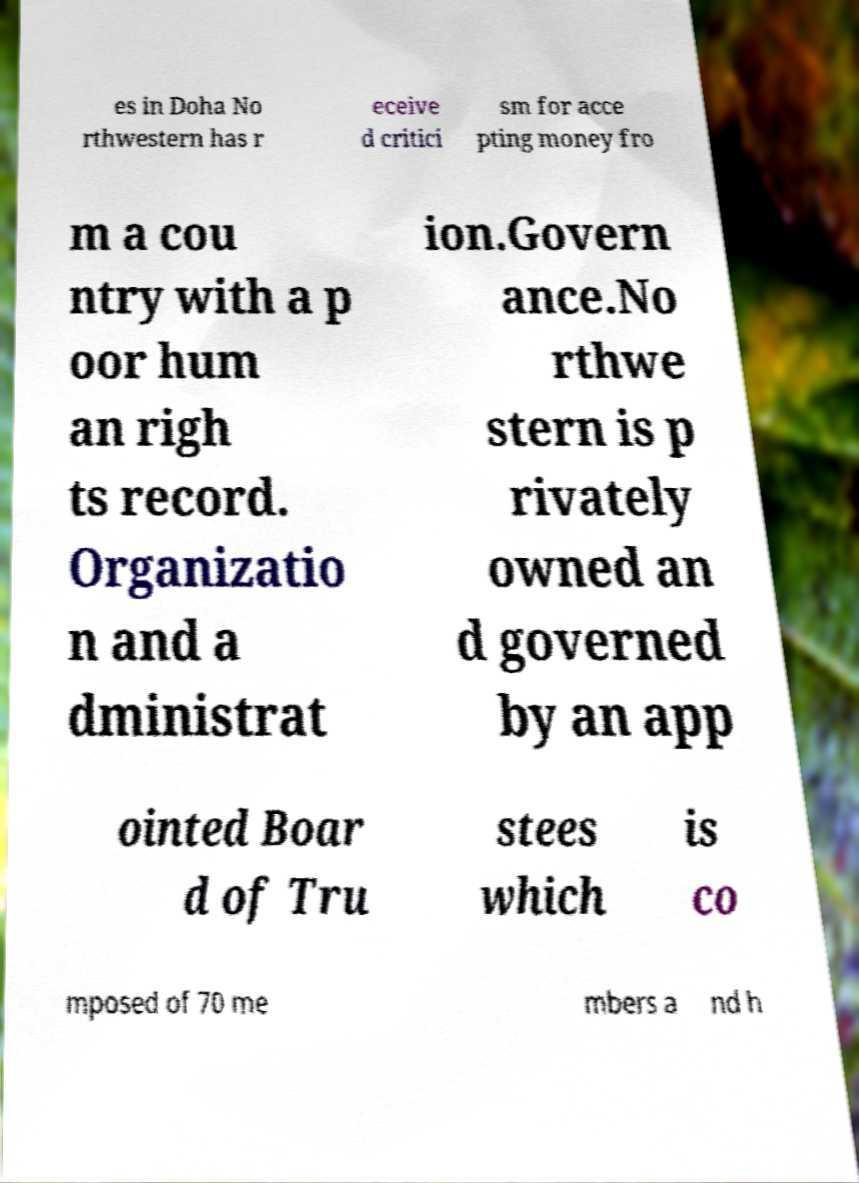What messages or text are displayed in this image? I need them in a readable, typed format. es in Doha No rthwestern has r eceive d critici sm for acce pting money fro m a cou ntry with a p oor hum an righ ts record. Organizatio n and a dministrat ion.Govern ance.No rthwe stern is p rivately owned an d governed by an app ointed Boar d of Tru stees which is co mposed of 70 me mbers a nd h 